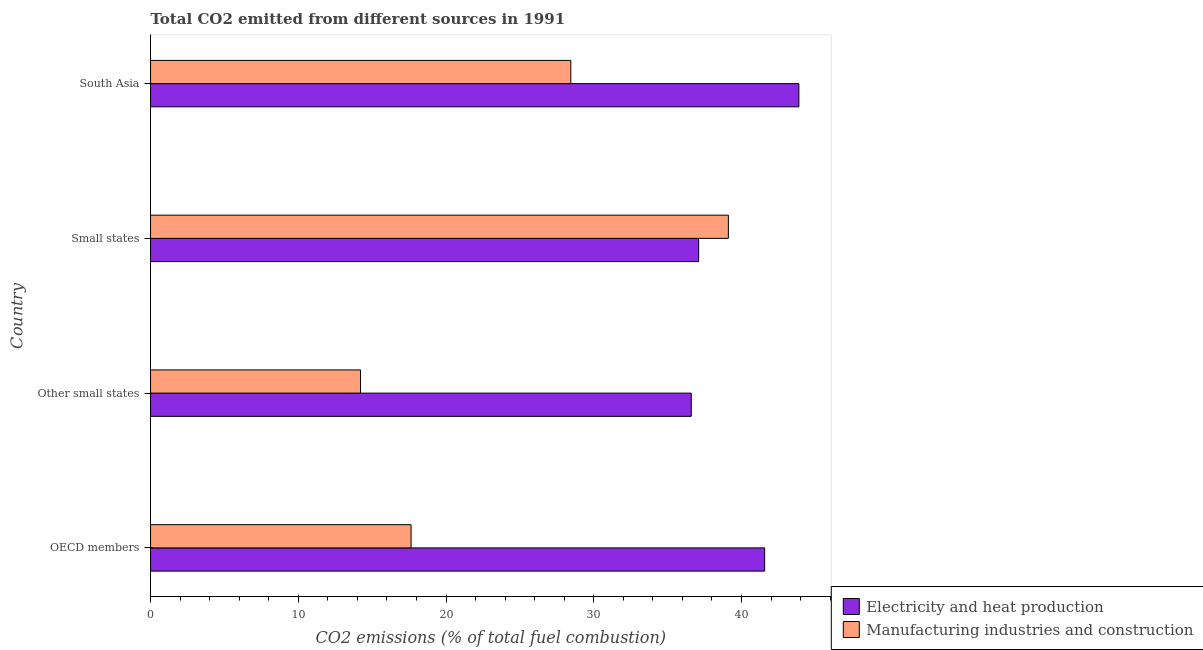How many groups of bars are there?
Your answer should be very brief. 4. Are the number of bars on each tick of the Y-axis equal?
Your response must be concise. Yes. What is the label of the 2nd group of bars from the top?
Give a very brief answer. Small states. In how many cases, is the number of bars for a given country not equal to the number of legend labels?
Provide a short and direct response. 0. What is the co2 emissions due to manufacturing industries in Other small states?
Offer a terse response. 14.22. Across all countries, what is the maximum co2 emissions due to manufacturing industries?
Ensure brevity in your answer.  39.11. Across all countries, what is the minimum co2 emissions due to electricity and heat production?
Offer a terse response. 36.6. In which country was the co2 emissions due to manufacturing industries maximum?
Offer a very short reply. Small states. In which country was the co2 emissions due to manufacturing industries minimum?
Make the answer very short. Other small states. What is the total co2 emissions due to electricity and heat production in the graph?
Offer a very short reply. 159.16. What is the difference between the co2 emissions due to manufacturing industries in OECD members and that in Other small states?
Offer a terse response. 3.42. What is the difference between the co2 emissions due to manufacturing industries in South Asia and the co2 emissions due to electricity and heat production in Small states?
Make the answer very short. -8.65. What is the average co2 emissions due to electricity and heat production per country?
Provide a succinct answer. 39.79. What is the difference between the co2 emissions due to electricity and heat production and co2 emissions due to manufacturing industries in Other small states?
Give a very brief answer. 22.39. In how many countries, is the co2 emissions due to manufacturing industries greater than 12 %?
Keep it short and to the point. 4. What is the ratio of the co2 emissions due to electricity and heat production in Other small states to that in South Asia?
Provide a short and direct response. 0.83. Is the co2 emissions due to electricity and heat production in OECD members less than that in Other small states?
Your answer should be compact. No. Is the difference between the co2 emissions due to manufacturing industries in Other small states and Small states greater than the difference between the co2 emissions due to electricity and heat production in Other small states and Small states?
Keep it short and to the point. No. What is the difference between the highest and the second highest co2 emissions due to electricity and heat production?
Give a very brief answer. 2.31. What is the difference between the highest and the lowest co2 emissions due to electricity and heat production?
Your answer should be compact. 7.29. Is the sum of the co2 emissions due to manufacturing industries in Small states and South Asia greater than the maximum co2 emissions due to electricity and heat production across all countries?
Offer a very short reply. Yes. What does the 1st bar from the top in South Asia represents?
Your answer should be compact. Manufacturing industries and construction. What does the 1st bar from the bottom in OECD members represents?
Make the answer very short. Electricity and heat production. Are all the bars in the graph horizontal?
Make the answer very short. Yes. Are the values on the major ticks of X-axis written in scientific E-notation?
Your answer should be compact. No. Does the graph contain any zero values?
Offer a very short reply. No. Does the graph contain grids?
Your answer should be very brief. No. Where does the legend appear in the graph?
Ensure brevity in your answer.  Bottom right. How many legend labels are there?
Offer a terse response. 2. How are the legend labels stacked?
Ensure brevity in your answer.  Vertical. What is the title of the graph?
Keep it short and to the point. Total CO2 emitted from different sources in 1991. What is the label or title of the X-axis?
Offer a terse response. CO2 emissions (% of total fuel combustion). What is the label or title of the Y-axis?
Offer a very short reply. Country. What is the CO2 emissions (% of total fuel combustion) of Electricity and heat production in OECD members?
Make the answer very short. 41.57. What is the CO2 emissions (% of total fuel combustion) in Manufacturing industries and construction in OECD members?
Provide a succinct answer. 17.64. What is the CO2 emissions (% of total fuel combustion) in Electricity and heat production in Other small states?
Provide a short and direct response. 36.6. What is the CO2 emissions (% of total fuel combustion) in Manufacturing industries and construction in Other small states?
Keep it short and to the point. 14.22. What is the CO2 emissions (% of total fuel combustion) of Electricity and heat production in Small states?
Ensure brevity in your answer.  37.1. What is the CO2 emissions (% of total fuel combustion) in Manufacturing industries and construction in Small states?
Your response must be concise. 39.11. What is the CO2 emissions (% of total fuel combustion) in Electricity and heat production in South Asia?
Make the answer very short. 43.89. What is the CO2 emissions (% of total fuel combustion) of Manufacturing industries and construction in South Asia?
Offer a terse response. 28.45. Across all countries, what is the maximum CO2 emissions (% of total fuel combustion) of Electricity and heat production?
Offer a terse response. 43.89. Across all countries, what is the maximum CO2 emissions (% of total fuel combustion) of Manufacturing industries and construction?
Make the answer very short. 39.11. Across all countries, what is the minimum CO2 emissions (% of total fuel combustion) of Electricity and heat production?
Your answer should be compact. 36.6. Across all countries, what is the minimum CO2 emissions (% of total fuel combustion) in Manufacturing industries and construction?
Give a very brief answer. 14.22. What is the total CO2 emissions (% of total fuel combustion) in Electricity and heat production in the graph?
Keep it short and to the point. 159.16. What is the total CO2 emissions (% of total fuel combustion) of Manufacturing industries and construction in the graph?
Keep it short and to the point. 99.42. What is the difference between the CO2 emissions (% of total fuel combustion) of Electricity and heat production in OECD members and that in Other small states?
Provide a short and direct response. 4.97. What is the difference between the CO2 emissions (% of total fuel combustion) of Manufacturing industries and construction in OECD members and that in Other small states?
Offer a very short reply. 3.42. What is the difference between the CO2 emissions (% of total fuel combustion) in Electricity and heat production in OECD members and that in Small states?
Keep it short and to the point. 4.47. What is the difference between the CO2 emissions (% of total fuel combustion) of Manufacturing industries and construction in OECD members and that in Small states?
Make the answer very short. -21.48. What is the difference between the CO2 emissions (% of total fuel combustion) in Electricity and heat production in OECD members and that in South Asia?
Your response must be concise. -2.31. What is the difference between the CO2 emissions (% of total fuel combustion) of Manufacturing industries and construction in OECD members and that in South Asia?
Your answer should be compact. -10.81. What is the difference between the CO2 emissions (% of total fuel combustion) in Electricity and heat production in Other small states and that in Small states?
Offer a very short reply. -0.5. What is the difference between the CO2 emissions (% of total fuel combustion) in Manufacturing industries and construction in Other small states and that in Small states?
Give a very brief answer. -24.9. What is the difference between the CO2 emissions (% of total fuel combustion) of Electricity and heat production in Other small states and that in South Asia?
Your answer should be very brief. -7.29. What is the difference between the CO2 emissions (% of total fuel combustion) of Manufacturing industries and construction in Other small states and that in South Asia?
Make the answer very short. -14.23. What is the difference between the CO2 emissions (% of total fuel combustion) in Electricity and heat production in Small states and that in South Asia?
Ensure brevity in your answer.  -6.78. What is the difference between the CO2 emissions (% of total fuel combustion) of Manufacturing industries and construction in Small states and that in South Asia?
Provide a short and direct response. 10.67. What is the difference between the CO2 emissions (% of total fuel combustion) in Electricity and heat production in OECD members and the CO2 emissions (% of total fuel combustion) in Manufacturing industries and construction in Other small states?
Your answer should be compact. 27.36. What is the difference between the CO2 emissions (% of total fuel combustion) of Electricity and heat production in OECD members and the CO2 emissions (% of total fuel combustion) of Manufacturing industries and construction in Small states?
Your answer should be compact. 2.46. What is the difference between the CO2 emissions (% of total fuel combustion) of Electricity and heat production in OECD members and the CO2 emissions (% of total fuel combustion) of Manufacturing industries and construction in South Asia?
Provide a succinct answer. 13.12. What is the difference between the CO2 emissions (% of total fuel combustion) in Electricity and heat production in Other small states and the CO2 emissions (% of total fuel combustion) in Manufacturing industries and construction in Small states?
Provide a succinct answer. -2.51. What is the difference between the CO2 emissions (% of total fuel combustion) in Electricity and heat production in Other small states and the CO2 emissions (% of total fuel combustion) in Manufacturing industries and construction in South Asia?
Keep it short and to the point. 8.15. What is the difference between the CO2 emissions (% of total fuel combustion) in Electricity and heat production in Small states and the CO2 emissions (% of total fuel combustion) in Manufacturing industries and construction in South Asia?
Keep it short and to the point. 8.65. What is the average CO2 emissions (% of total fuel combustion) in Electricity and heat production per country?
Make the answer very short. 39.79. What is the average CO2 emissions (% of total fuel combustion) in Manufacturing industries and construction per country?
Your answer should be very brief. 24.85. What is the difference between the CO2 emissions (% of total fuel combustion) of Electricity and heat production and CO2 emissions (% of total fuel combustion) of Manufacturing industries and construction in OECD members?
Keep it short and to the point. 23.94. What is the difference between the CO2 emissions (% of total fuel combustion) in Electricity and heat production and CO2 emissions (% of total fuel combustion) in Manufacturing industries and construction in Other small states?
Provide a succinct answer. 22.39. What is the difference between the CO2 emissions (% of total fuel combustion) of Electricity and heat production and CO2 emissions (% of total fuel combustion) of Manufacturing industries and construction in Small states?
Provide a short and direct response. -2.01. What is the difference between the CO2 emissions (% of total fuel combustion) in Electricity and heat production and CO2 emissions (% of total fuel combustion) in Manufacturing industries and construction in South Asia?
Provide a short and direct response. 15.44. What is the ratio of the CO2 emissions (% of total fuel combustion) in Electricity and heat production in OECD members to that in Other small states?
Offer a terse response. 1.14. What is the ratio of the CO2 emissions (% of total fuel combustion) of Manufacturing industries and construction in OECD members to that in Other small states?
Offer a very short reply. 1.24. What is the ratio of the CO2 emissions (% of total fuel combustion) in Electricity and heat production in OECD members to that in Small states?
Ensure brevity in your answer.  1.12. What is the ratio of the CO2 emissions (% of total fuel combustion) of Manufacturing industries and construction in OECD members to that in Small states?
Give a very brief answer. 0.45. What is the ratio of the CO2 emissions (% of total fuel combustion) in Electricity and heat production in OECD members to that in South Asia?
Keep it short and to the point. 0.95. What is the ratio of the CO2 emissions (% of total fuel combustion) in Manufacturing industries and construction in OECD members to that in South Asia?
Offer a terse response. 0.62. What is the ratio of the CO2 emissions (% of total fuel combustion) in Electricity and heat production in Other small states to that in Small states?
Your response must be concise. 0.99. What is the ratio of the CO2 emissions (% of total fuel combustion) of Manufacturing industries and construction in Other small states to that in Small states?
Your response must be concise. 0.36. What is the ratio of the CO2 emissions (% of total fuel combustion) in Electricity and heat production in Other small states to that in South Asia?
Your response must be concise. 0.83. What is the ratio of the CO2 emissions (% of total fuel combustion) in Manufacturing industries and construction in Other small states to that in South Asia?
Your answer should be compact. 0.5. What is the ratio of the CO2 emissions (% of total fuel combustion) in Electricity and heat production in Small states to that in South Asia?
Your answer should be compact. 0.85. What is the ratio of the CO2 emissions (% of total fuel combustion) in Manufacturing industries and construction in Small states to that in South Asia?
Your response must be concise. 1.37. What is the difference between the highest and the second highest CO2 emissions (% of total fuel combustion) in Electricity and heat production?
Make the answer very short. 2.31. What is the difference between the highest and the second highest CO2 emissions (% of total fuel combustion) in Manufacturing industries and construction?
Keep it short and to the point. 10.67. What is the difference between the highest and the lowest CO2 emissions (% of total fuel combustion) of Electricity and heat production?
Ensure brevity in your answer.  7.29. What is the difference between the highest and the lowest CO2 emissions (% of total fuel combustion) in Manufacturing industries and construction?
Provide a succinct answer. 24.9. 